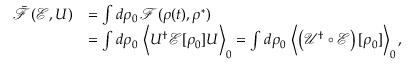<formula> <loc_0><loc_0><loc_500><loc_500>\begin{array} { r l } { \bar { \mathcal { F } } ( \mathcal { E } , U ) } & { = \int d \rho _ { 0 } \, \mathcal { F } ( { \rho ( t ) } , \rho ^ { * } ) } \\ & { = \int d \rho _ { 0 } \, \left \langle U ^ { \dagger } \mathcal { E } [ \rho _ { 0 } ] U \right \rangle _ { 0 } = \int d \rho _ { 0 } \, \left \langle \left ( \mathcal { U ^ { \dag } \circ E } \right ) [ \rho _ { 0 } ] \right \rangle _ { 0 } , } \end{array}</formula> 